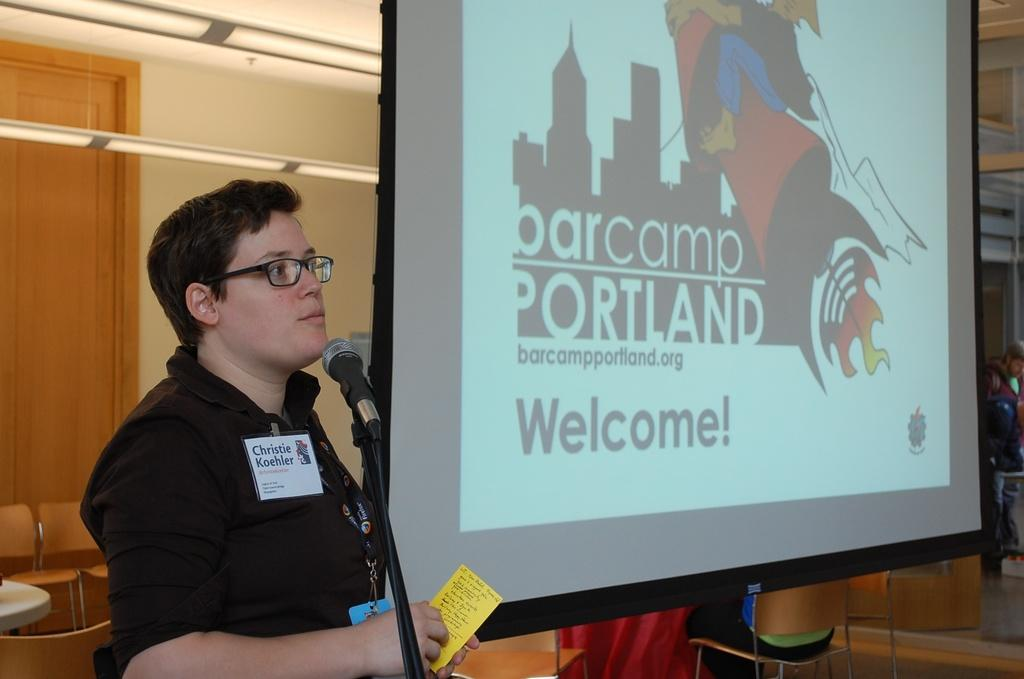What is the person in the image wearing? The person in the image is wearing a black dress. What is the person holding in the image? The person is holding a yellow card. What can be seen near the person in the image? There is a microphone in the image. What type of furniture is present in the image? There is a stand and chairs in the image. What is the purpose of the projection screen in the image? The projection screen is likely used for displaying visuals or presentations. What architectural features can be seen in the image? There is a wall and a door in the image. What type of history can be seen in the image? There is no history present in the image; it is a snapshot of a person, objects, and architectural features. How many snakes are visible in the image? There are no snakes present in the image. 